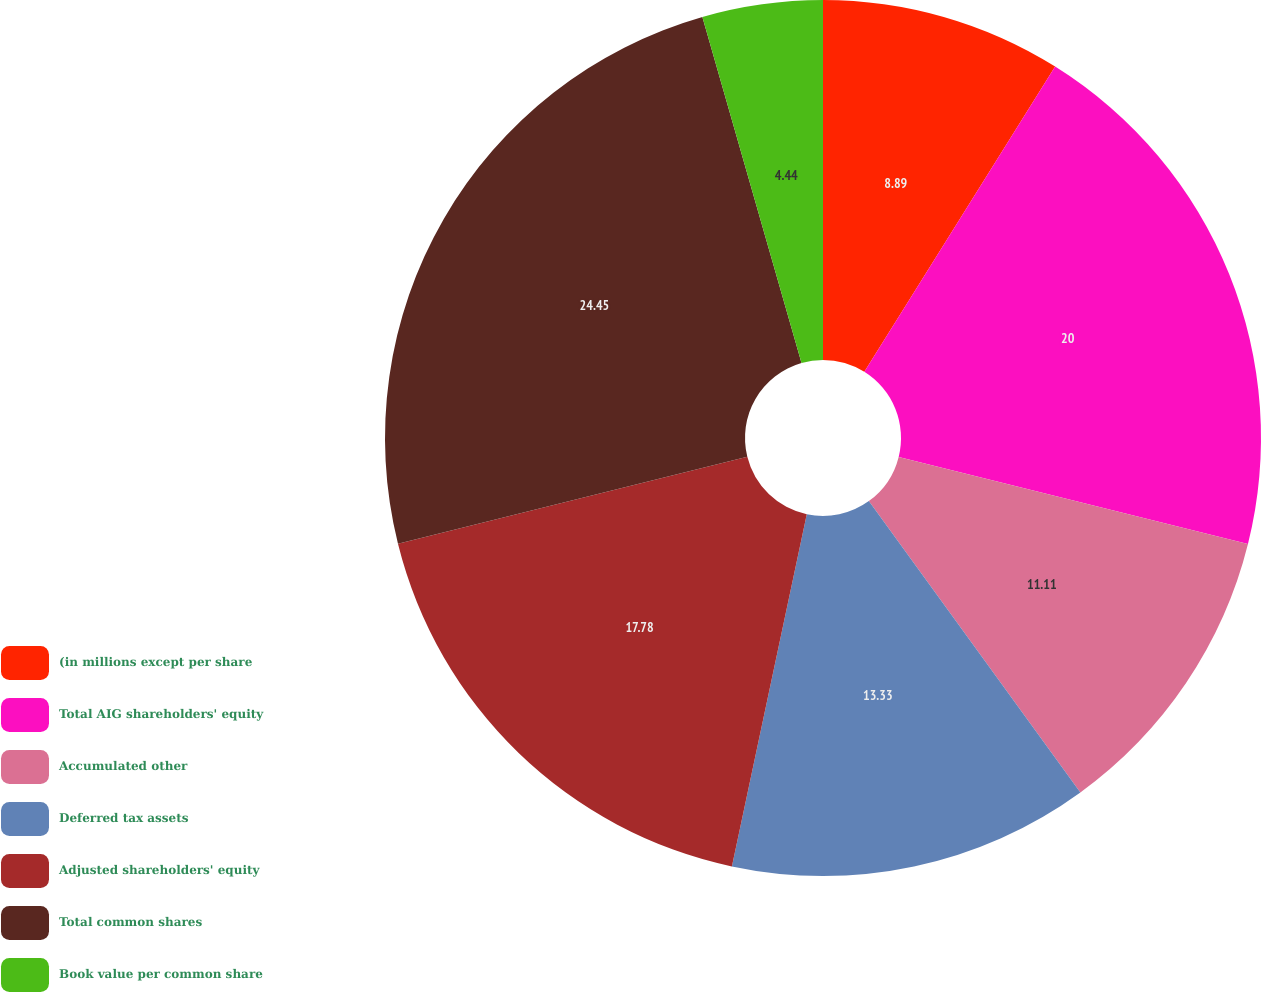<chart> <loc_0><loc_0><loc_500><loc_500><pie_chart><fcel>(in millions except per share<fcel>Total AIG shareholders' equity<fcel>Accumulated other<fcel>Deferred tax assets<fcel>Adjusted shareholders' equity<fcel>Total common shares<fcel>Book value per common share<nl><fcel>8.89%<fcel>20.0%<fcel>11.11%<fcel>13.33%<fcel>17.78%<fcel>24.44%<fcel>4.44%<nl></chart> 